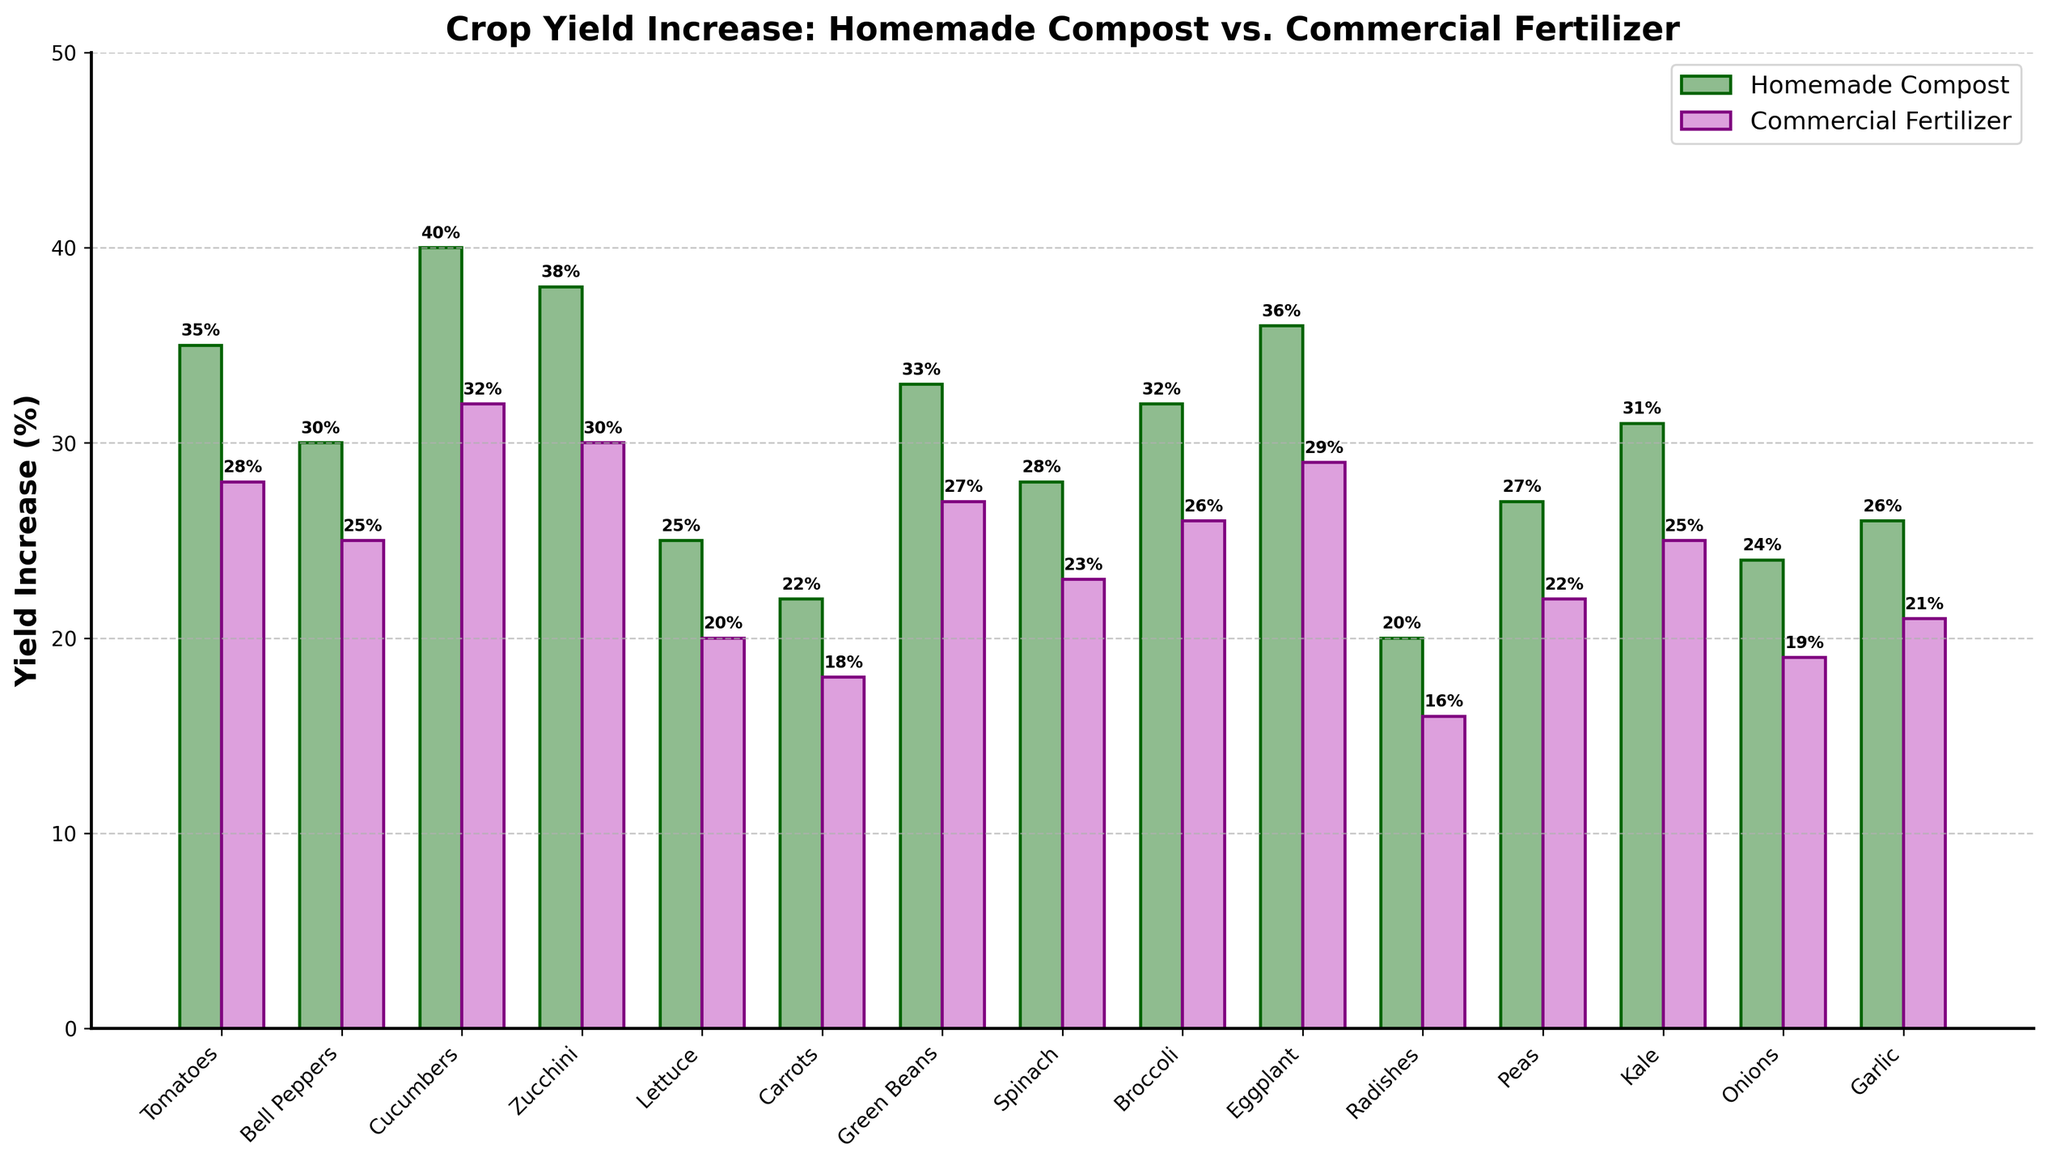Which vegetable shows the highest yield increase with homemade compost? By observing the heights of the bars, the vegetable with the tallest bar in the homemade compost category represents the highest yield increase. This is Cucumbers.
Answer: Cucumbers Which vegetable has a higher yield increase with commercial fertilizer compared to homemade compost? By comparing the heights of the bars for each vegetable, we see no vegetable with a taller commercial fertilizer bar than the corresponding homemade compost bar. Thus, no vegetable has a higher yield increase with commercial fertilizer.
Answer: None What's the average yield increase for all vegetables using homemade compost? Sum all the percentages for yield increase with homemade compost and divide by the number of vegetables. (35+30+40+38+25+22+33+28+32+36+20+27+31+24+26) / 15 = 487 / 15 = 32.47
Answer: 32.47% Compare the yield increase of tomatoes and carrots using both homemade compost and commercial fertilizer. Which has the higher increase? For homemade compost, tomatoes have 35% and carrots 22%. For commercial fertilizer, tomatoes have 28% and carrots 18%. Tomatoes have a higher yield increase in both cases.
Answer: Tomatoes How much more yield increase does lettuce get with homemade compost compared to commercial fertilizer? Subtract the yield increase with commercial fertilizer from the yield increase with homemade compost for lettuce. 25% - 20% = 5%
Answer: 5% Among the green vegetables (like spinach, kale, broccoli, etc.), which one has the lowest yield increase with commercial fertilizer? From the bar heights, it can be seen that spinach has the lowest yield increase among the green vegetables with commercial fertilizer at 23%.
Answer: Spinach What are the three vegetables with the smallest yield increase difference between homemade compost and commercial fertilizer? Calculate the differences for each vegetable and identify the smallest three. Radishes (4%), Carrots (4%), Onions (5%)
Answer: Radishes, Carrots, Onions For which vegetable is the yield increase percent with homemade compost exactly 10% more than with commercial fertilizer? For each vegetable, check if the homemade compost yield increase is 10% more than the commercial fertilizer yield increase. This is true for Zucchini (38% - 30% = 8%)
Answer: None Which vegetable shows the highest total yield increase percentage (homemade compost + commercial fertilizer)? Sum the yield increases for both methods for each vegetable and find the highest. Cucumbers have the highest total yield increase (40% + 32% = 72%).
Answer: Cucumbers Which vegetable has the closest yield increase percentages for homemade compost and commercial fertilizer? Find the vegetable with the smallest difference between the two methods. Radishes have 20% for homemade compost and 16% for commercial fertilizer, with a difference of 4%.
Answer: Radishes 